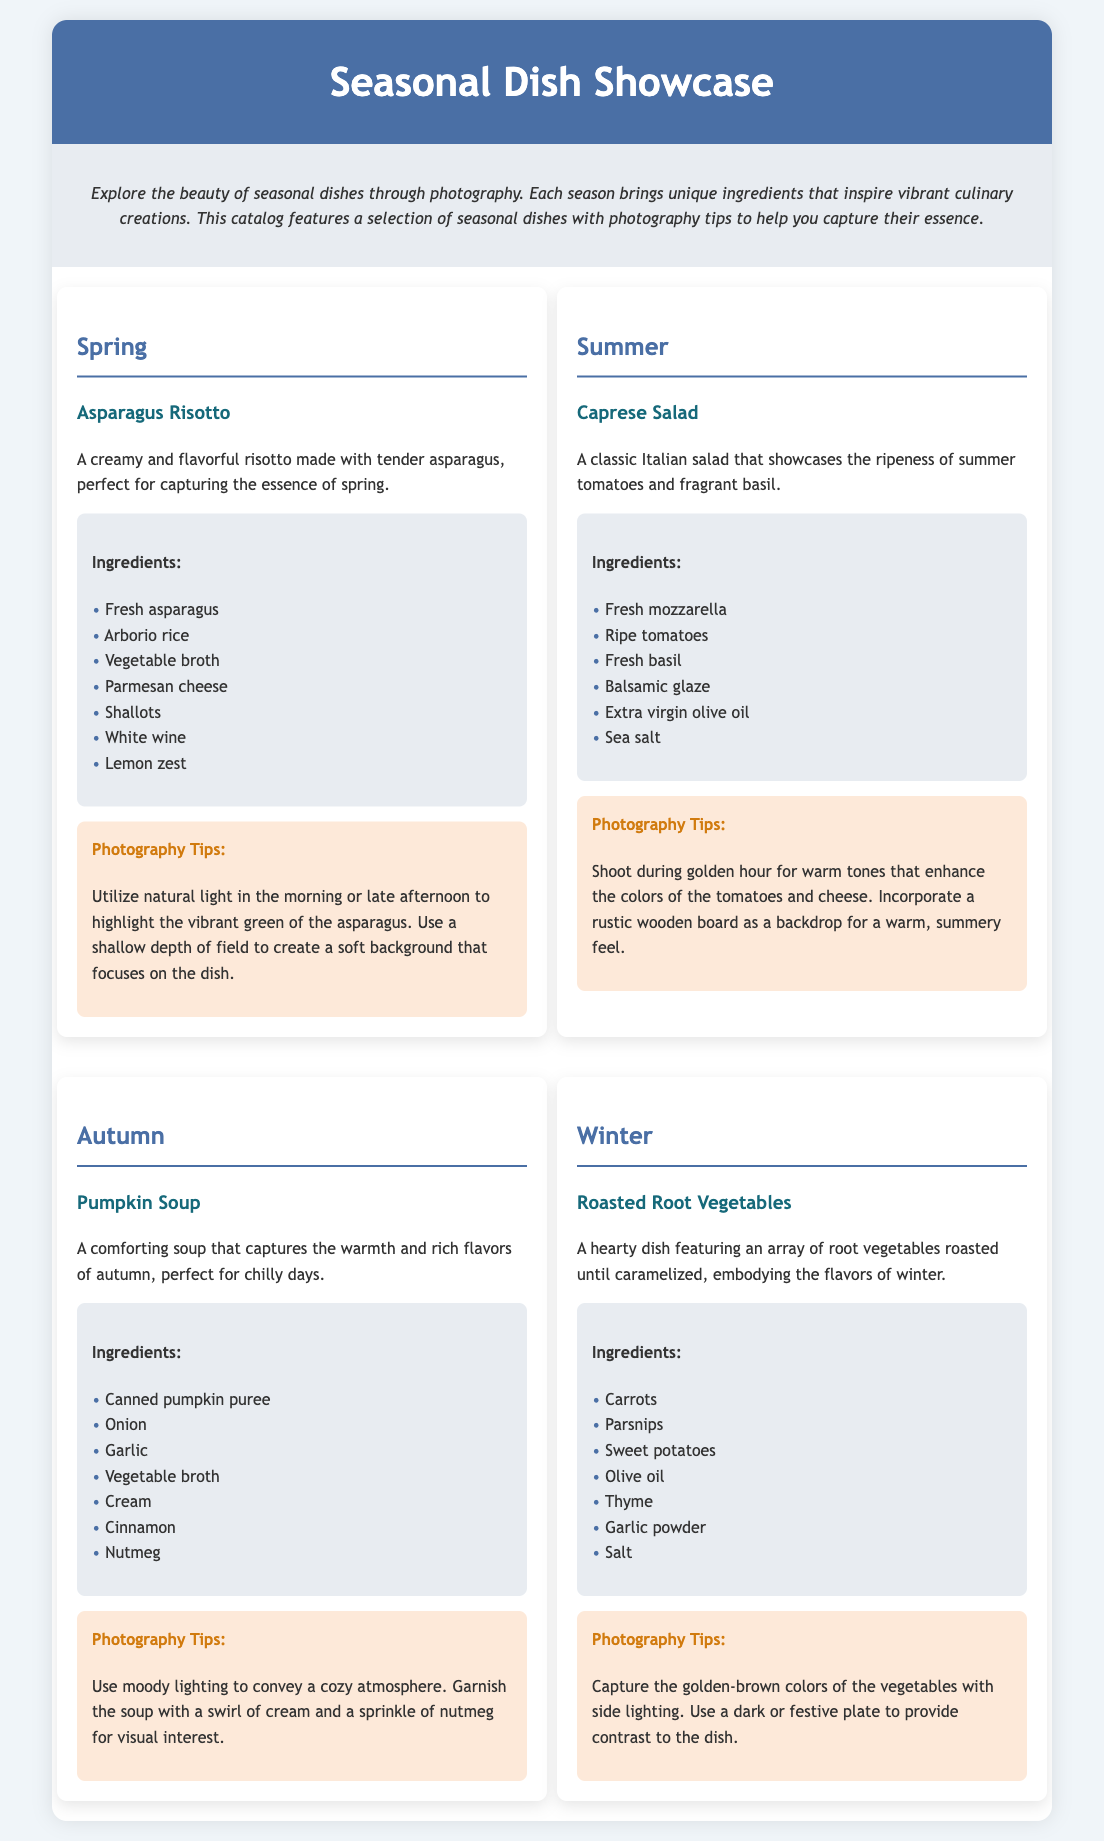What is the first dish showcased in spring? The first dish listed under spring is Asparagus Risotto.
Answer: Asparagus Risotto How many ingredients are listed for the Caprese Salad? There are six ingredients listed for the Caprese Salad.
Answer: 6 Which season features Pumpkin Soup? The season featuring Pumpkin Soup is autumn.
Answer: Autumn What photography tip is suggested for capturing Asparagus Risotto? The tip suggests utilizing natural light in the morning or late afternoon.
Answer: Utilize natural light in the morning or late afternoon What color theme is used for the header background? The header background color is described as #4a6fa5.
Answer: #4a6fa5 Which dish is recommended for winter? The dish recommended for winter is Roasted Root Vegetables.
Answer: Roasted Root Vegetables What ingredient is common in both the Autumn and Winter sections? The common ingredient in both sections is garlic.
Answer: Garlic What is the overall theme of the catalog? The overall theme of the catalog is seasonal dishes and photography tips.
Answer: Seasonal dishes and photography tips 